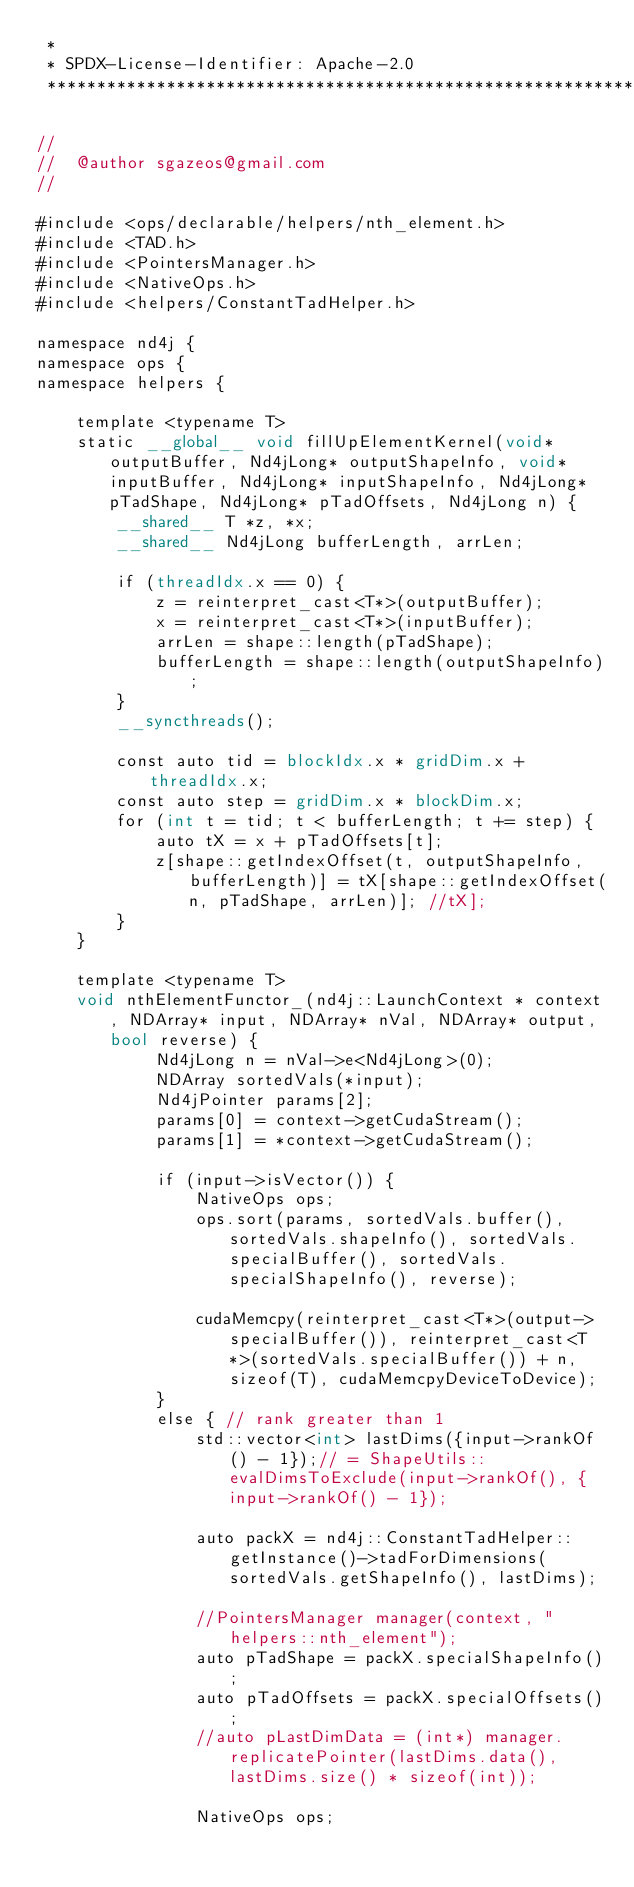<code> <loc_0><loc_0><loc_500><loc_500><_Cuda_> *
 * SPDX-License-Identifier: Apache-2.0
 ******************************************************************************/

//
//  @author sgazeos@gmail.com
//

#include <ops/declarable/helpers/nth_element.h>
#include <TAD.h>
#include <PointersManager.h>
#include <NativeOps.h>
#include <helpers/ConstantTadHelper.h>

namespace nd4j {
namespace ops {
namespace helpers {

    template <typename T>
    static __global__ void fillUpElementKernel(void* outputBuffer, Nd4jLong* outputShapeInfo, void* inputBuffer, Nd4jLong* inputShapeInfo, Nd4jLong* pTadShape, Nd4jLong* pTadOffsets, Nd4jLong n) {
        __shared__ T *z, *x;
        __shared__ Nd4jLong bufferLength, arrLen;

        if (threadIdx.x == 0) {
            z = reinterpret_cast<T*>(outputBuffer);
            x = reinterpret_cast<T*>(inputBuffer);
            arrLen = shape::length(pTadShape);
            bufferLength = shape::length(outputShapeInfo);
        }
        __syncthreads();

        const auto tid = blockIdx.x * gridDim.x + threadIdx.x;
        const auto step = gridDim.x * blockDim.x;
        for (int t = tid; t < bufferLength; t += step) {
            auto tX = x + pTadOffsets[t];
            z[shape::getIndexOffset(t, outputShapeInfo, bufferLength)] = tX[shape::getIndexOffset(n, pTadShape, arrLen)]; //tX];
        }
    }

    template <typename T>
    void nthElementFunctor_(nd4j::LaunchContext * context, NDArray* input, NDArray* nVal, NDArray* output, bool reverse) {
            Nd4jLong n = nVal->e<Nd4jLong>(0);
            NDArray sortedVals(*input);
            Nd4jPointer params[2];
            params[0] = context->getCudaStream();
            params[1] = *context->getCudaStream();

            if (input->isVector()) {
                NativeOps ops;
                ops.sort(params, sortedVals.buffer(), sortedVals.shapeInfo(), sortedVals.specialBuffer(), sortedVals.specialShapeInfo(), reverse);

                cudaMemcpy(reinterpret_cast<T*>(output->specialBuffer()), reinterpret_cast<T*>(sortedVals.specialBuffer()) + n, sizeof(T), cudaMemcpyDeviceToDevice);
            }
            else { // rank greater than 1
                std::vector<int> lastDims({input->rankOf() - 1});// = ShapeUtils::evalDimsToExclude(input->rankOf(), {input->rankOf() - 1});

                auto packX = nd4j::ConstantTadHelper::getInstance()->tadForDimensions(sortedVals.getShapeInfo(), lastDims);

                //PointersManager manager(context, "helpers::nth_element");
                auto pTadShape = packX.specialShapeInfo();
                auto pTadOffsets = packX.specialOffsets();
                //auto pLastDimData = (int*) manager.replicatePointer(lastDims.data(), lastDims.size() * sizeof(int));

                NativeOps ops;</code> 